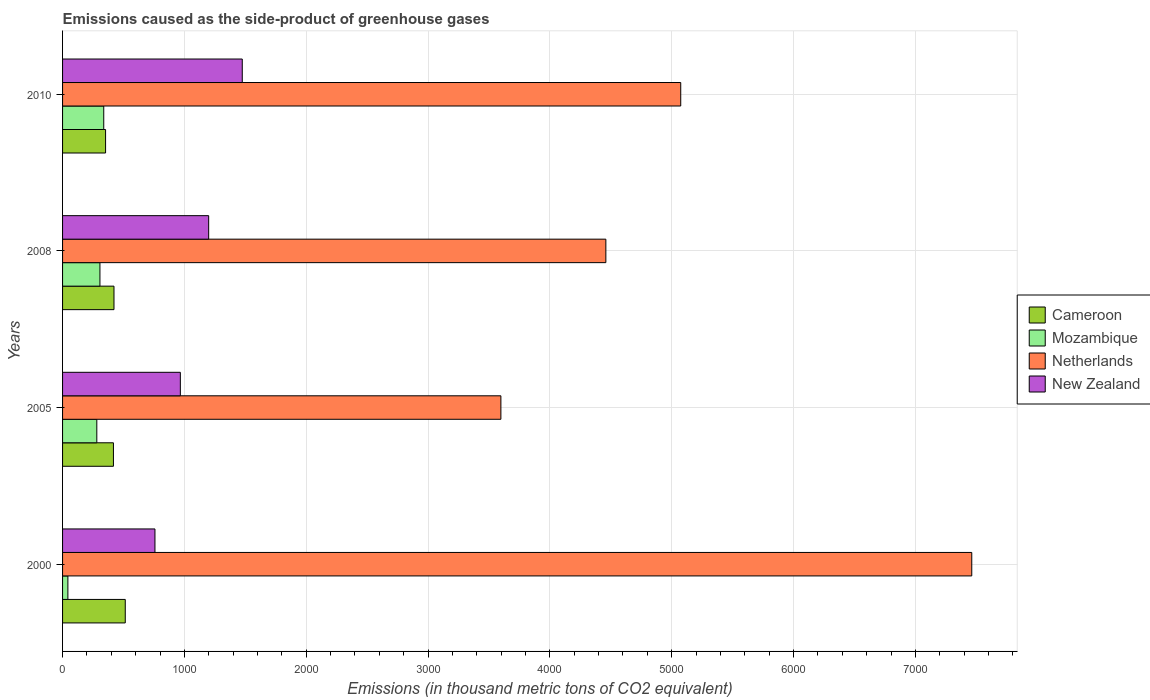How many different coloured bars are there?
Your response must be concise. 4. How many groups of bars are there?
Your response must be concise. 4. Are the number of bars on each tick of the Y-axis equal?
Your response must be concise. Yes. What is the label of the 2nd group of bars from the top?
Your answer should be compact. 2008. In how many cases, is the number of bars for a given year not equal to the number of legend labels?
Make the answer very short. 0. What is the emissions caused as the side-product of greenhouse gases in New Zealand in 2010?
Your answer should be compact. 1475. Across all years, what is the maximum emissions caused as the side-product of greenhouse gases in New Zealand?
Your response must be concise. 1475. Across all years, what is the minimum emissions caused as the side-product of greenhouse gases in New Zealand?
Ensure brevity in your answer.  758.3. In which year was the emissions caused as the side-product of greenhouse gases in Cameroon maximum?
Your response must be concise. 2000. In which year was the emissions caused as the side-product of greenhouse gases in Netherlands minimum?
Your answer should be very brief. 2005. What is the total emissions caused as the side-product of greenhouse gases in Mozambique in the graph?
Your answer should be very brief. 969.6. What is the difference between the emissions caused as the side-product of greenhouse gases in Mozambique in 2000 and that in 2005?
Make the answer very short. -237.4. What is the difference between the emissions caused as the side-product of greenhouse gases in Cameroon in 2005 and the emissions caused as the side-product of greenhouse gases in Mozambique in 2000?
Provide a succinct answer. 373.8. What is the average emissions caused as the side-product of greenhouse gases in New Zealand per year?
Offer a terse response. 1099.83. In the year 2005, what is the difference between the emissions caused as the side-product of greenhouse gases in New Zealand and emissions caused as the side-product of greenhouse gases in Netherlands?
Your response must be concise. -2631.1. What is the ratio of the emissions caused as the side-product of greenhouse gases in Mozambique in 2000 to that in 2010?
Offer a very short reply. 0.13. Is the emissions caused as the side-product of greenhouse gases in Cameroon in 2005 less than that in 2010?
Offer a very short reply. No. Is the difference between the emissions caused as the side-product of greenhouse gases in New Zealand in 2000 and 2005 greater than the difference between the emissions caused as the side-product of greenhouse gases in Netherlands in 2000 and 2005?
Provide a succinct answer. No. What is the difference between the highest and the second highest emissions caused as the side-product of greenhouse gases in Mozambique?
Your response must be concise. 31.2. What is the difference between the highest and the lowest emissions caused as the side-product of greenhouse gases in Mozambique?
Keep it short and to the point. 294.3. In how many years, is the emissions caused as the side-product of greenhouse gases in Netherlands greater than the average emissions caused as the side-product of greenhouse gases in Netherlands taken over all years?
Offer a terse response. 1. What does the 4th bar from the top in 2008 represents?
Provide a succinct answer. Cameroon. What does the 2nd bar from the bottom in 2008 represents?
Offer a very short reply. Mozambique. Is it the case that in every year, the sum of the emissions caused as the side-product of greenhouse gases in Mozambique and emissions caused as the side-product of greenhouse gases in New Zealand is greater than the emissions caused as the side-product of greenhouse gases in Cameroon?
Your answer should be very brief. Yes. Are all the bars in the graph horizontal?
Offer a terse response. Yes. How many years are there in the graph?
Your response must be concise. 4. Are the values on the major ticks of X-axis written in scientific E-notation?
Provide a succinct answer. No. Does the graph contain grids?
Your answer should be very brief. Yes. What is the title of the graph?
Give a very brief answer. Emissions caused as the side-product of greenhouse gases. What is the label or title of the X-axis?
Provide a succinct answer. Emissions (in thousand metric tons of CO2 equivalent). What is the label or title of the Y-axis?
Provide a short and direct response. Years. What is the Emissions (in thousand metric tons of CO2 equivalent) in Cameroon in 2000?
Provide a succinct answer. 514.7. What is the Emissions (in thousand metric tons of CO2 equivalent) in Mozambique in 2000?
Ensure brevity in your answer.  43.7. What is the Emissions (in thousand metric tons of CO2 equivalent) in Netherlands in 2000?
Provide a short and direct response. 7462.9. What is the Emissions (in thousand metric tons of CO2 equivalent) in New Zealand in 2000?
Provide a short and direct response. 758.3. What is the Emissions (in thousand metric tons of CO2 equivalent) of Cameroon in 2005?
Keep it short and to the point. 417.5. What is the Emissions (in thousand metric tons of CO2 equivalent) in Mozambique in 2005?
Your answer should be very brief. 281.1. What is the Emissions (in thousand metric tons of CO2 equivalent) of Netherlands in 2005?
Your answer should be compact. 3597.8. What is the Emissions (in thousand metric tons of CO2 equivalent) in New Zealand in 2005?
Give a very brief answer. 966.7. What is the Emissions (in thousand metric tons of CO2 equivalent) in Cameroon in 2008?
Your answer should be very brief. 422.1. What is the Emissions (in thousand metric tons of CO2 equivalent) in Mozambique in 2008?
Keep it short and to the point. 306.8. What is the Emissions (in thousand metric tons of CO2 equivalent) in Netherlands in 2008?
Offer a terse response. 4459.4. What is the Emissions (in thousand metric tons of CO2 equivalent) in New Zealand in 2008?
Make the answer very short. 1199.3. What is the Emissions (in thousand metric tons of CO2 equivalent) in Cameroon in 2010?
Your answer should be compact. 353. What is the Emissions (in thousand metric tons of CO2 equivalent) in Mozambique in 2010?
Ensure brevity in your answer.  338. What is the Emissions (in thousand metric tons of CO2 equivalent) of Netherlands in 2010?
Your response must be concise. 5074. What is the Emissions (in thousand metric tons of CO2 equivalent) in New Zealand in 2010?
Give a very brief answer. 1475. Across all years, what is the maximum Emissions (in thousand metric tons of CO2 equivalent) of Cameroon?
Ensure brevity in your answer.  514.7. Across all years, what is the maximum Emissions (in thousand metric tons of CO2 equivalent) in Mozambique?
Offer a very short reply. 338. Across all years, what is the maximum Emissions (in thousand metric tons of CO2 equivalent) in Netherlands?
Your answer should be compact. 7462.9. Across all years, what is the maximum Emissions (in thousand metric tons of CO2 equivalent) of New Zealand?
Provide a short and direct response. 1475. Across all years, what is the minimum Emissions (in thousand metric tons of CO2 equivalent) in Cameroon?
Offer a terse response. 353. Across all years, what is the minimum Emissions (in thousand metric tons of CO2 equivalent) of Mozambique?
Make the answer very short. 43.7. Across all years, what is the minimum Emissions (in thousand metric tons of CO2 equivalent) in Netherlands?
Keep it short and to the point. 3597.8. Across all years, what is the minimum Emissions (in thousand metric tons of CO2 equivalent) in New Zealand?
Your answer should be very brief. 758.3. What is the total Emissions (in thousand metric tons of CO2 equivalent) in Cameroon in the graph?
Ensure brevity in your answer.  1707.3. What is the total Emissions (in thousand metric tons of CO2 equivalent) of Mozambique in the graph?
Offer a terse response. 969.6. What is the total Emissions (in thousand metric tons of CO2 equivalent) in Netherlands in the graph?
Provide a succinct answer. 2.06e+04. What is the total Emissions (in thousand metric tons of CO2 equivalent) in New Zealand in the graph?
Keep it short and to the point. 4399.3. What is the difference between the Emissions (in thousand metric tons of CO2 equivalent) of Cameroon in 2000 and that in 2005?
Offer a terse response. 97.2. What is the difference between the Emissions (in thousand metric tons of CO2 equivalent) in Mozambique in 2000 and that in 2005?
Provide a short and direct response. -237.4. What is the difference between the Emissions (in thousand metric tons of CO2 equivalent) of Netherlands in 2000 and that in 2005?
Make the answer very short. 3865.1. What is the difference between the Emissions (in thousand metric tons of CO2 equivalent) in New Zealand in 2000 and that in 2005?
Your answer should be compact. -208.4. What is the difference between the Emissions (in thousand metric tons of CO2 equivalent) in Cameroon in 2000 and that in 2008?
Ensure brevity in your answer.  92.6. What is the difference between the Emissions (in thousand metric tons of CO2 equivalent) of Mozambique in 2000 and that in 2008?
Your response must be concise. -263.1. What is the difference between the Emissions (in thousand metric tons of CO2 equivalent) of Netherlands in 2000 and that in 2008?
Offer a very short reply. 3003.5. What is the difference between the Emissions (in thousand metric tons of CO2 equivalent) in New Zealand in 2000 and that in 2008?
Your answer should be very brief. -441. What is the difference between the Emissions (in thousand metric tons of CO2 equivalent) in Cameroon in 2000 and that in 2010?
Make the answer very short. 161.7. What is the difference between the Emissions (in thousand metric tons of CO2 equivalent) of Mozambique in 2000 and that in 2010?
Give a very brief answer. -294.3. What is the difference between the Emissions (in thousand metric tons of CO2 equivalent) in Netherlands in 2000 and that in 2010?
Your answer should be compact. 2388.9. What is the difference between the Emissions (in thousand metric tons of CO2 equivalent) in New Zealand in 2000 and that in 2010?
Give a very brief answer. -716.7. What is the difference between the Emissions (in thousand metric tons of CO2 equivalent) of Mozambique in 2005 and that in 2008?
Provide a succinct answer. -25.7. What is the difference between the Emissions (in thousand metric tons of CO2 equivalent) of Netherlands in 2005 and that in 2008?
Offer a terse response. -861.6. What is the difference between the Emissions (in thousand metric tons of CO2 equivalent) of New Zealand in 2005 and that in 2008?
Keep it short and to the point. -232.6. What is the difference between the Emissions (in thousand metric tons of CO2 equivalent) in Cameroon in 2005 and that in 2010?
Keep it short and to the point. 64.5. What is the difference between the Emissions (in thousand metric tons of CO2 equivalent) in Mozambique in 2005 and that in 2010?
Offer a very short reply. -56.9. What is the difference between the Emissions (in thousand metric tons of CO2 equivalent) of Netherlands in 2005 and that in 2010?
Give a very brief answer. -1476.2. What is the difference between the Emissions (in thousand metric tons of CO2 equivalent) of New Zealand in 2005 and that in 2010?
Give a very brief answer. -508.3. What is the difference between the Emissions (in thousand metric tons of CO2 equivalent) in Cameroon in 2008 and that in 2010?
Give a very brief answer. 69.1. What is the difference between the Emissions (in thousand metric tons of CO2 equivalent) in Mozambique in 2008 and that in 2010?
Keep it short and to the point. -31.2. What is the difference between the Emissions (in thousand metric tons of CO2 equivalent) in Netherlands in 2008 and that in 2010?
Give a very brief answer. -614.6. What is the difference between the Emissions (in thousand metric tons of CO2 equivalent) in New Zealand in 2008 and that in 2010?
Make the answer very short. -275.7. What is the difference between the Emissions (in thousand metric tons of CO2 equivalent) in Cameroon in 2000 and the Emissions (in thousand metric tons of CO2 equivalent) in Mozambique in 2005?
Give a very brief answer. 233.6. What is the difference between the Emissions (in thousand metric tons of CO2 equivalent) in Cameroon in 2000 and the Emissions (in thousand metric tons of CO2 equivalent) in Netherlands in 2005?
Your answer should be very brief. -3083.1. What is the difference between the Emissions (in thousand metric tons of CO2 equivalent) in Cameroon in 2000 and the Emissions (in thousand metric tons of CO2 equivalent) in New Zealand in 2005?
Your response must be concise. -452. What is the difference between the Emissions (in thousand metric tons of CO2 equivalent) of Mozambique in 2000 and the Emissions (in thousand metric tons of CO2 equivalent) of Netherlands in 2005?
Ensure brevity in your answer.  -3554.1. What is the difference between the Emissions (in thousand metric tons of CO2 equivalent) in Mozambique in 2000 and the Emissions (in thousand metric tons of CO2 equivalent) in New Zealand in 2005?
Give a very brief answer. -923. What is the difference between the Emissions (in thousand metric tons of CO2 equivalent) in Netherlands in 2000 and the Emissions (in thousand metric tons of CO2 equivalent) in New Zealand in 2005?
Provide a short and direct response. 6496.2. What is the difference between the Emissions (in thousand metric tons of CO2 equivalent) of Cameroon in 2000 and the Emissions (in thousand metric tons of CO2 equivalent) of Mozambique in 2008?
Offer a very short reply. 207.9. What is the difference between the Emissions (in thousand metric tons of CO2 equivalent) in Cameroon in 2000 and the Emissions (in thousand metric tons of CO2 equivalent) in Netherlands in 2008?
Provide a short and direct response. -3944.7. What is the difference between the Emissions (in thousand metric tons of CO2 equivalent) of Cameroon in 2000 and the Emissions (in thousand metric tons of CO2 equivalent) of New Zealand in 2008?
Provide a succinct answer. -684.6. What is the difference between the Emissions (in thousand metric tons of CO2 equivalent) of Mozambique in 2000 and the Emissions (in thousand metric tons of CO2 equivalent) of Netherlands in 2008?
Give a very brief answer. -4415.7. What is the difference between the Emissions (in thousand metric tons of CO2 equivalent) of Mozambique in 2000 and the Emissions (in thousand metric tons of CO2 equivalent) of New Zealand in 2008?
Provide a succinct answer. -1155.6. What is the difference between the Emissions (in thousand metric tons of CO2 equivalent) of Netherlands in 2000 and the Emissions (in thousand metric tons of CO2 equivalent) of New Zealand in 2008?
Give a very brief answer. 6263.6. What is the difference between the Emissions (in thousand metric tons of CO2 equivalent) of Cameroon in 2000 and the Emissions (in thousand metric tons of CO2 equivalent) of Mozambique in 2010?
Your answer should be very brief. 176.7. What is the difference between the Emissions (in thousand metric tons of CO2 equivalent) of Cameroon in 2000 and the Emissions (in thousand metric tons of CO2 equivalent) of Netherlands in 2010?
Provide a short and direct response. -4559.3. What is the difference between the Emissions (in thousand metric tons of CO2 equivalent) in Cameroon in 2000 and the Emissions (in thousand metric tons of CO2 equivalent) in New Zealand in 2010?
Your answer should be compact. -960.3. What is the difference between the Emissions (in thousand metric tons of CO2 equivalent) in Mozambique in 2000 and the Emissions (in thousand metric tons of CO2 equivalent) in Netherlands in 2010?
Ensure brevity in your answer.  -5030.3. What is the difference between the Emissions (in thousand metric tons of CO2 equivalent) of Mozambique in 2000 and the Emissions (in thousand metric tons of CO2 equivalent) of New Zealand in 2010?
Your answer should be compact. -1431.3. What is the difference between the Emissions (in thousand metric tons of CO2 equivalent) in Netherlands in 2000 and the Emissions (in thousand metric tons of CO2 equivalent) in New Zealand in 2010?
Your answer should be very brief. 5987.9. What is the difference between the Emissions (in thousand metric tons of CO2 equivalent) of Cameroon in 2005 and the Emissions (in thousand metric tons of CO2 equivalent) of Mozambique in 2008?
Make the answer very short. 110.7. What is the difference between the Emissions (in thousand metric tons of CO2 equivalent) in Cameroon in 2005 and the Emissions (in thousand metric tons of CO2 equivalent) in Netherlands in 2008?
Your answer should be very brief. -4041.9. What is the difference between the Emissions (in thousand metric tons of CO2 equivalent) of Cameroon in 2005 and the Emissions (in thousand metric tons of CO2 equivalent) of New Zealand in 2008?
Your response must be concise. -781.8. What is the difference between the Emissions (in thousand metric tons of CO2 equivalent) in Mozambique in 2005 and the Emissions (in thousand metric tons of CO2 equivalent) in Netherlands in 2008?
Ensure brevity in your answer.  -4178.3. What is the difference between the Emissions (in thousand metric tons of CO2 equivalent) in Mozambique in 2005 and the Emissions (in thousand metric tons of CO2 equivalent) in New Zealand in 2008?
Ensure brevity in your answer.  -918.2. What is the difference between the Emissions (in thousand metric tons of CO2 equivalent) in Netherlands in 2005 and the Emissions (in thousand metric tons of CO2 equivalent) in New Zealand in 2008?
Your answer should be compact. 2398.5. What is the difference between the Emissions (in thousand metric tons of CO2 equivalent) of Cameroon in 2005 and the Emissions (in thousand metric tons of CO2 equivalent) of Mozambique in 2010?
Offer a terse response. 79.5. What is the difference between the Emissions (in thousand metric tons of CO2 equivalent) of Cameroon in 2005 and the Emissions (in thousand metric tons of CO2 equivalent) of Netherlands in 2010?
Keep it short and to the point. -4656.5. What is the difference between the Emissions (in thousand metric tons of CO2 equivalent) in Cameroon in 2005 and the Emissions (in thousand metric tons of CO2 equivalent) in New Zealand in 2010?
Make the answer very short. -1057.5. What is the difference between the Emissions (in thousand metric tons of CO2 equivalent) of Mozambique in 2005 and the Emissions (in thousand metric tons of CO2 equivalent) of Netherlands in 2010?
Provide a short and direct response. -4792.9. What is the difference between the Emissions (in thousand metric tons of CO2 equivalent) of Mozambique in 2005 and the Emissions (in thousand metric tons of CO2 equivalent) of New Zealand in 2010?
Provide a short and direct response. -1193.9. What is the difference between the Emissions (in thousand metric tons of CO2 equivalent) of Netherlands in 2005 and the Emissions (in thousand metric tons of CO2 equivalent) of New Zealand in 2010?
Offer a very short reply. 2122.8. What is the difference between the Emissions (in thousand metric tons of CO2 equivalent) of Cameroon in 2008 and the Emissions (in thousand metric tons of CO2 equivalent) of Mozambique in 2010?
Your answer should be compact. 84.1. What is the difference between the Emissions (in thousand metric tons of CO2 equivalent) in Cameroon in 2008 and the Emissions (in thousand metric tons of CO2 equivalent) in Netherlands in 2010?
Your response must be concise. -4651.9. What is the difference between the Emissions (in thousand metric tons of CO2 equivalent) of Cameroon in 2008 and the Emissions (in thousand metric tons of CO2 equivalent) of New Zealand in 2010?
Your answer should be compact. -1052.9. What is the difference between the Emissions (in thousand metric tons of CO2 equivalent) of Mozambique in 2008 and the Emissions (in thousand metric tons of CO2 equivalent) of Netherlands in 2010?
Provide a short and direct response. -4767.2. What is the difference between the Emissions (in thousand metric tons of CO2 equivalent) of Mozambique in 2008 and the Emissions (in thousand metric tons of CO2 equivalent) of New Zealand in 2010?
Give a very brief answer. -1168.2. What is the difference between the Emissions (in thousand metric tons of CO2 equivalent) of Netherlands in 2008 and the Emissions (in thousand metric tons of CO2 equivalent) of New Zealand in 2010?
Give a very brief answer. 2984.4. What is the average Emissions (in thousand metric tons of CO2 equivalent) of Cameroon per year?
Provide a short and direct response. 426.82. What is the average Emissions (in thousand metric tons of CO2 equivalent) of Mozambique per year?
Offer a terse response. 242.4. What is the average Emissions (in thousand metric tons of CO2 equivalent) of Netherlands per year?
Your answer should be compact. 5148.52. What is the average Emissions (in thousand metric tons of CO2 equivalent) of New Zealand per year?
Offer a very short reply. 1099.83. In the year 2000, what is the difference between the Emissions (in thousand metric tons of CO2 equivalent) of Cameroon and Emissions (in thousand metric tons of CO2 equivalent) of Mozambique?
Provide a short and direct response. 471. In the year 2000, what is the difference between the Emissions (in thousand metric tons of CO2 equivalent) in Cameroon and Emissions (in thousand metric tons of CO2 equivalent) in Netherlands?
Offer a very short reply. -6948.2. In the year 2000, what is the difference between the Emissions (in thousand metric tons of CO2 equivalent) of Cameroon and Emissions (in thousand metric tons of CO2 equivalent) of New Zealand?
Provide a short and direct response. -243.6. In the year 2000, what is the difference between the Emissions (in thousand metric tons of CO2 equivalent) of Mozambique and Emissions (in thousand metric tons of CO2 equivalent) of Netherlands?
Offer a very short reply. -7419.2. In the year 2000, what is the difference between the Emissions (in thousand metric tons of CO2 equivalent) in Mozambique and Emissions (in thousand metric tons of CO2 equivalent) in New Zealand?
Your response must be concise. -714.6. In the year 2000, what is the difference between the Emissions (in thousand metric tons of CO2 equivalent) in Netherlands and Emissions (in thousand metric tons of CO2 equivalent) in New Zealand?
Your response must be concise. 6704.6. In the year 2005, what is the difference between the Emissions (in thousand metric tons of CO2 equivalent) of Cameroon and Emissions (in thousand metric tons of CO2 equivalent) of Mozambique?
Provide a succinct answer. 136.4. In the year 2005, what is the difference between the Emissions (in thousand metric tons of CO2 equivalent) of Cameroon and Emissions (in thousand metric tons of CO2 equivalent) of Netherlands?
Provide a succinct answer. -3180.3. In the year 2005, what is the difference between the Emissions (in thousand metric tons of CO2 equivalent) in Cameroon and Emissions (in thousand metric tons of CO2 equivalent) in New Zealand?
Ensure brevity in your answer.  -549.2. In the year 2005, what is the difference between the Emissions (in thousand metric tons of CO2 equivalent) of Mozambique and Emissions (in thousand metric tons of CO2 equivalent) of Netherlands?
Provide a succinct answer. -3316.7. In the year 2005, what is the difference between the Emissions (in thousand metric tons of CO2 equivalent) in Mozambique and Emissions (in thousand metric tons of CO2 equivalent) in New Zealand?
Give a very brief answer. -685.6. In the year 2005, what is the difference between the Emissions (in thousand metric tons of CO2 equivalent) of Netherlands and Emissions (in thousand metric tons of CO2 equivalent) of New Zealand?
Provide a succinct answer. 2631.1. In the year 2008, what is the difference between the Emissions (in thousand metric tons of CO2 equivalent) of Cameroon and Emissions (in thousand metric tons of CO2 equivalent) of Mozambique?
Your answer should be very brief. 115.3. In the year 2008, what is the difference between the Emissions (in thousand metric tons of CO2 equivalent) in Cameroon and Emissions (in thousand metric tons of CO2 equivalent) in Netherlands?
Your response must be concise. -4037.3. In the year 2008, what is the difference between the Emissions (in thousand metric tons of CO2 equivalent) in Cameroon and Emissions (in thousand metric tons of CO2 equivalent) in New Zealand?
Your response must be concise. -777.2. In the year 2008, what is the difference between the Emissions (in thousand metric tons of CO2 equivalent) in Mozambique and Emissions (in thousand metric tons of CO2 equivalent) in Netherlands?
Offer a very short reply. -4152.6. In the year 2008, what is the difference between the Emissions (in thousand metric tons of CO2 equivalent) in Mozambique and Emissions (in thousand metric tons of CO2 equivalent) in New Zealand?
Make the answer very short. -892.5. In the year 2008, what is the difference between the Emissions (in thousand metric tons of CO2 equivalent) of Netherlands and Emissions (in thousand metric tons of CO2 equivalent) of New Zealand?
Give a very brief answer. 3260.1. In the year 2010, what is the difference between the Emissions (in thousand metric tons of CO2 equivalent) in Cameroon and Emissions (in thousand metric tons of CO2 equivalent) in Mozambique?
Offer a terse response. 15. In the year 2010, what is the difference between the Emissions (in thousand metric tons of CO2 equivalent) of Cameroon and Emissions (in thousand metric tons of CO2 equivalent) of Netherlands?
Keep it short and to the point. -4721. In the year 2010, what is the difference between the Emissions (in thousand metric tons of CO2 equivalent) of Cameroon and Emissions (in thousand metric tons of CO2 equivalent) of New Zealand?
Make the answer very short. -1122. In the year 2010, what is the difference between the Emissions (in thousand metric tons of CO2 equivalent) of Mozambique and Emissions (in thousand metric tons of CO2 equivalent) of Netherlands?
Provide a succinct answer. -4736. In the year 2010, what is the difference between the Emissions (in thousand metric tons of CO2 equivalent) in Mozambique and Emissions (in thousand metric tons of CO2 equivalent) in New Zealand?
Provide a short and direct response. -1137. In the year 2010, what is the difference between the Emissions (in thousand metric tons of CO2 equivalent) in Netherlands and Emissions (in thousand metric tons of CO2 equivalent) in New Zealand?
Your response must be concise. 3599. What is the ratio of the Emissions (in thousand metric tons of CO2 equivalent) in Cameroon in 2000 to that in 2005?
Offer a very short reply. 1.23. What is the ratio of the Emissions (in thousand metric tons of CO2 equivalent) of Mozambique in 2000 to that in 2005?
Your answer should be compact. 0.16. What is the ratio of the Emissions (in thousand metric tons of CO2 equivalent) of Netherlands in 2000 to that in 2005?
Ensure brevity in your answer.  2.07. What is the ratio of the Emissions (in thousand metric tons of CO2 equivalent) of New Zealand in 2000 to that in 2005?
Make the answer very short. 0.78. What is the ratio of the Emissions (in thousand metric tons of CO2 equivalent) in Cameroon in 2000 to that in 2008?
Provide a succinct answer. 1.22. What is the ratio of the Emissions (in thousand metric tons of CO2 equivalent) in Mozambique in 2000 to that in 2008?
Ensure brevity in your answer.  0.14. What is the ratio of the Emissions (in thousand metric tons of CO2 equivalent) of Netherlands in 2000 to that in 2008?
Ensure brevity in your answer.  1.67. What is the ratio of the Emissions (in thousand metric tons of CO2 equivalent) of New Zealand in 2000 to that in 2008?
Provide a succinct answer. 0.63. What is the ratio of the Emissions (in thousand metric tons of CO2 equivalent) of Cameroon in 2000 to that in 2010?
Offer a terse response. 1.46. What is the ratio of the Emissions (in thousand metric tons of CO2 equivalent) in Mozambique in 2000 to that in 2010?
Your answer should be compact. 0.13. What is the ratio of the Emissions (in thousand metric tons of CO2 equivalent) in Netherlands in 2000 to that in 2010?
Provide a short and direct response. 1.47. What is the ratio of the Emissions (in thousand metric tons of CO2 equivalent) of New Zealand in 2000 to that in 2010?
Offer a terse response. 0.51. What is the ratio of the Emissions (in thousand metric tons of CO2 equivalent) of Mozambique in 2005 to that in 2008?
Offer a terse response. 0.92. What is the ratio of the Emissions (in thousand metric tons of CO2 equivalent) of Netherlands in 2005 to that in 2008?
Your answer should be very brief. 0.81. What is the ratio of the Emissions (in thousand metric tons of CO2 equivalent) in New Zealand in 2005 to that in 2008?
Keep it short and to the point. 0.81. What is the ratio of the Emissions (in thousand metric tons of CO2 equivalent) of Cameroon in 2005 to that in 2010?
Keep it short and to the point. 1.18. What is the ratio of the Emissions (in thousand metric tons of CO2 equivalent) in Mozambique in 2005 to that in 2010?
Your response must be concise. 0.83. What is the ratio of the Emissions (in thousand metric tons of CO2 equivalent) in Netherlands in 2005 to that in 2010?
Offer a very short reply. 0.71. What is the ratio of the Emissions (in thousand metric tons of CO2 equivalent) of New Zealand in 2005 to that in 2010?
Ensure brevity in your answer.  0.66. What is the ratio of the Emissions (in thousand metric tons of CO2 equivalent) of Cameroon in 2008 to that in 2010?
Your answer should be compact. 1.2. What is the ratio of the Emissions (in thousand metric tons of CO2 equivalent) of Mozambique in 2008 to that in 2010?
Keep it short and to the point. 0.91. What is the ratio of the Emissions (in thousand metric tons of CO2 equivalent) in Netherlands in 2008 to that in 2010?
Your answer should be very brief. 0.88. What is the ratio of the Emissions (in thousand metric tons of CO2 equivalent) in New Zealand in 2008 to that in 2010?
Offer a very short reply. 0.81. What is the difference between the highest and the second highest Emissions (in thousand metric tons of CO2 equivalent) of Cameroon?
Offer a very short reply. 92.6. What is the difference between the highest and the second highest Emissions (in thousand metric tons of CO2 equivalent) of Mozambique?
Offer a terse response. 31.2. What is the difference between the highest and the second highest Emissions (in thousand metric tons of CO2 equivalent) in Netherlands?
Provide a short and direct response. 2388.9. What is the difference between the highest and the second highest Emissions (in thousand metric tons of CO2 equivalent) of New Zealand?
Your answer should be very brief. 275.7. What is the difference between the highest and the lowest Emissions (in thousand metric tons of CO2 equivalent) in Cameroon?
Make the answer very short. 161.7. What is the difference between the highest and the lowest Emissions (in thousand metric tons of CO2 equivalent) in Mozambique?
Keep it short and to the point. 294.3. What is the difference between the highest and the lowest Emissions (in thousand metric tons of CO2 equivalent) of Netherlands?
Your answer should be very brief. 3865.1. What is the difference between the highest and the lowest Emissions (in thousand metric tons of CO2 equivalent) of New Zealand?
Make the answer very short. 716.7. 